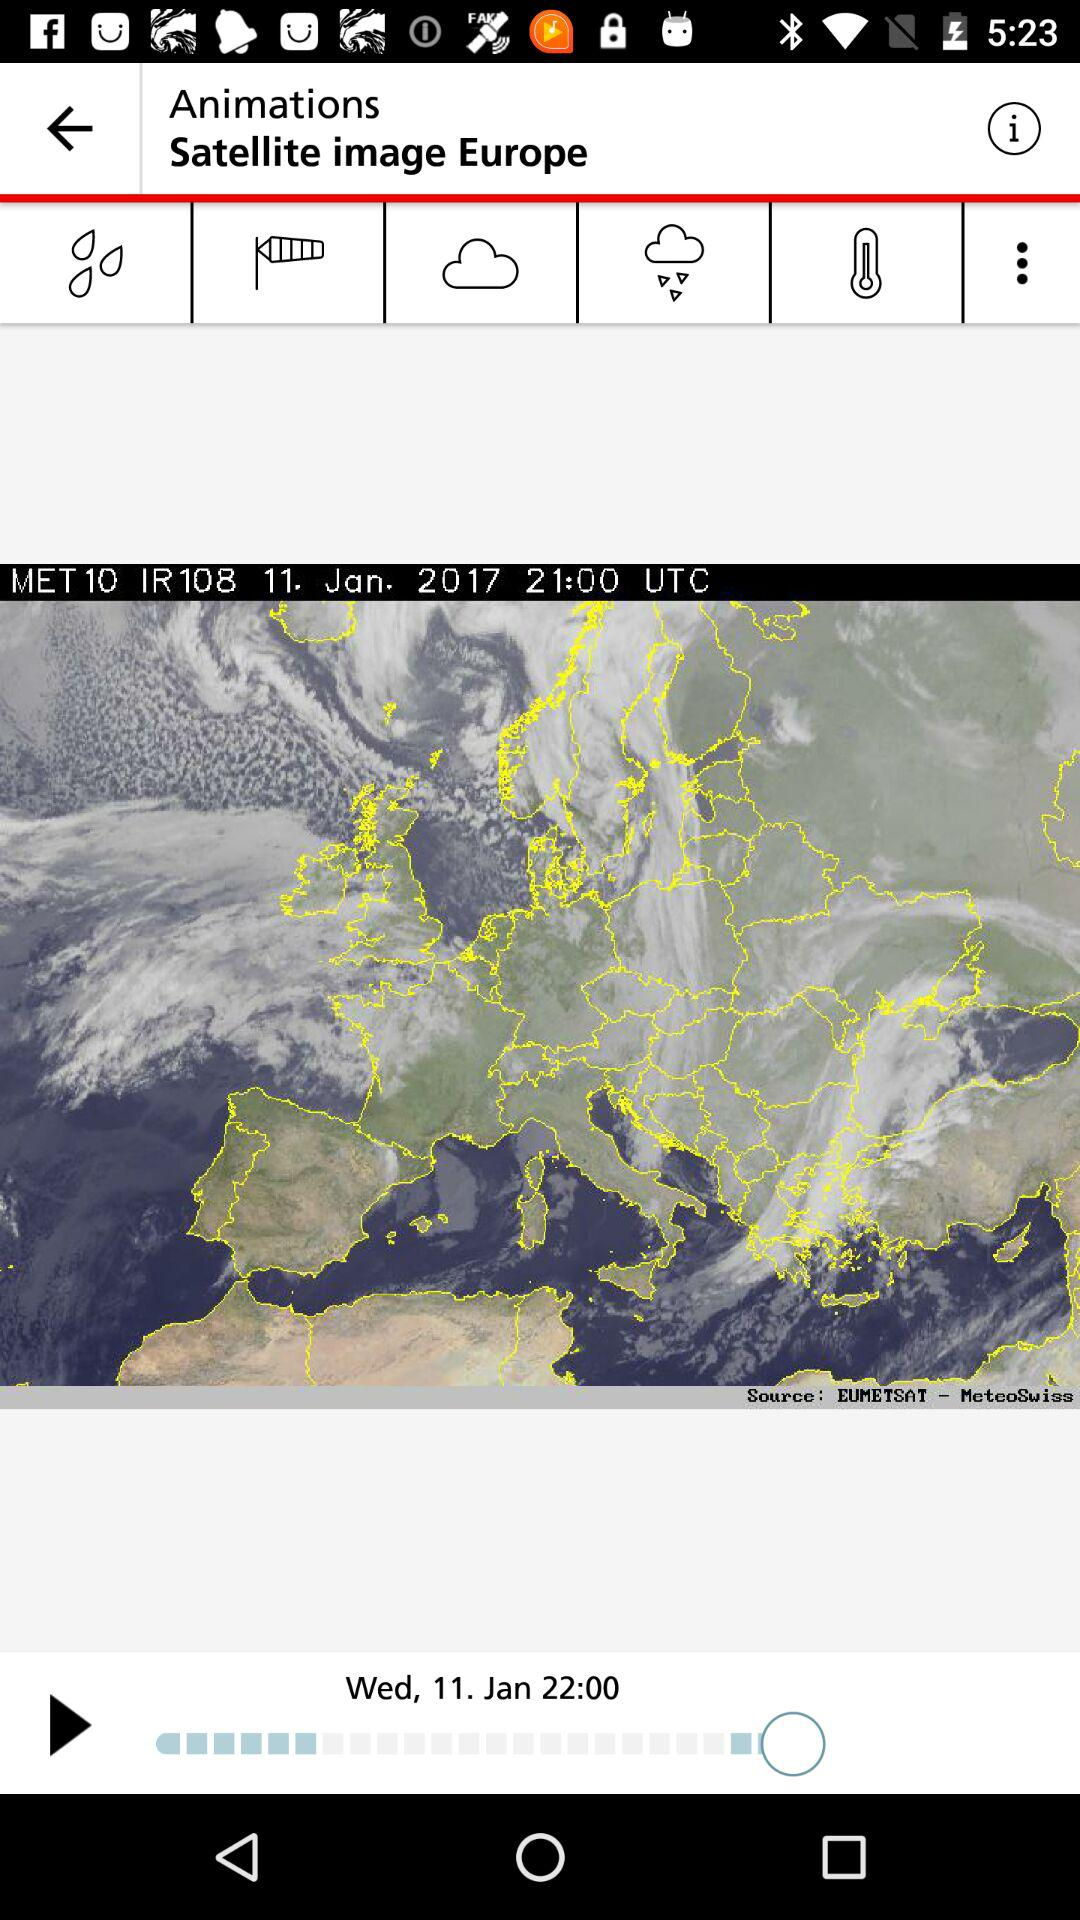At what time was the image captured? The image was captured at 21:00 UTC. 